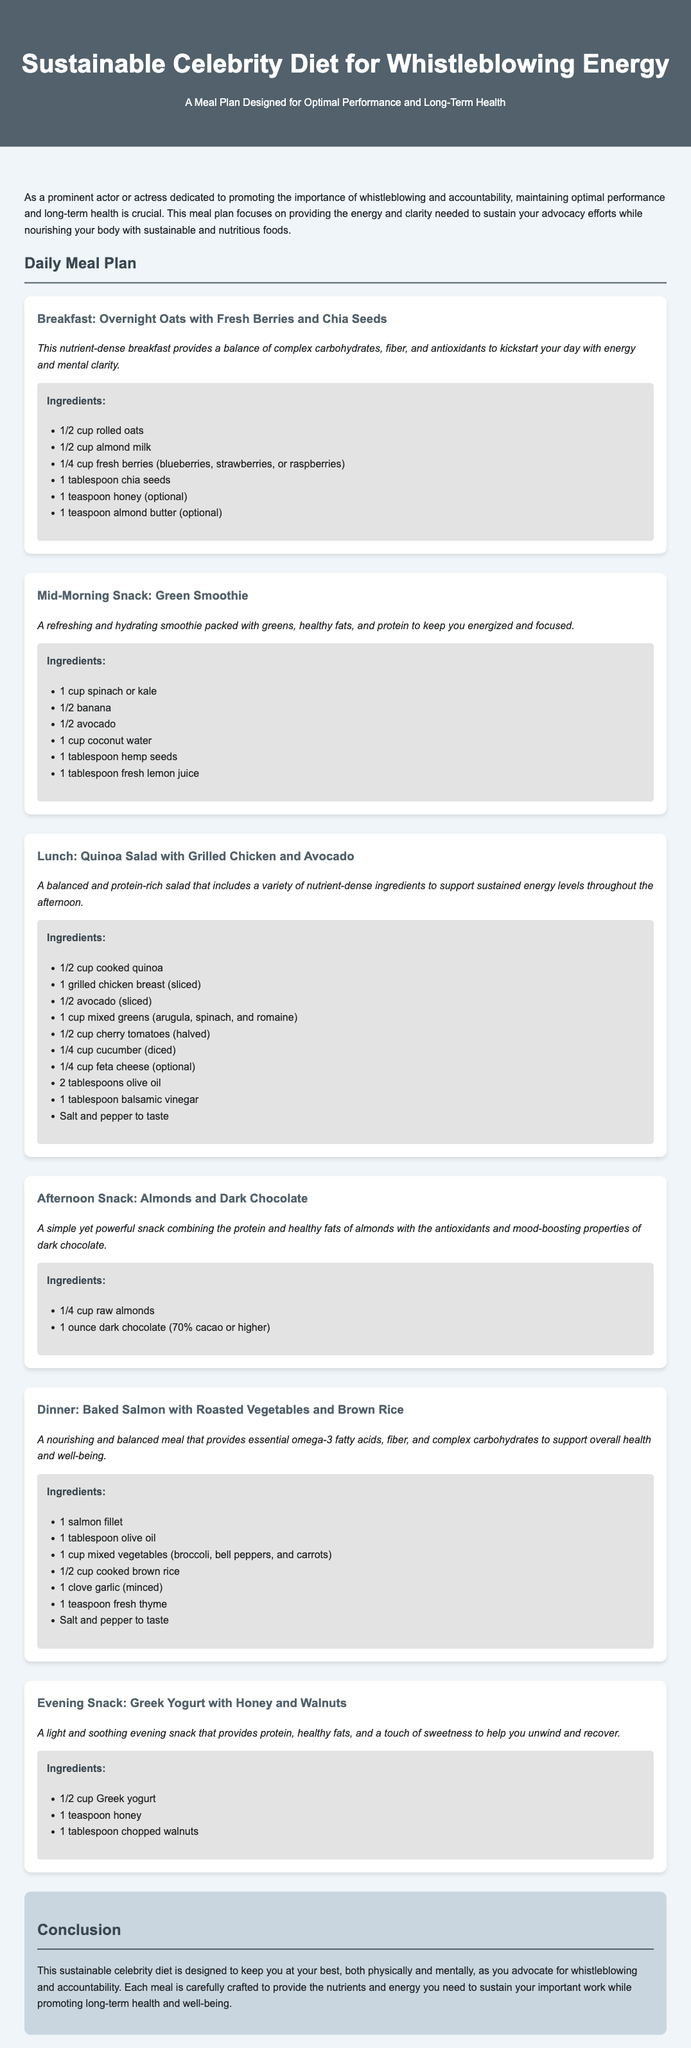What is the title of the meal plan? The title of the meal plan is prominently displayed at the top of the document.
Answer: Sustainable Celebrity Diet for Whistleblowing Energy How many meals are included in the daily meal plan? The daily meal plan consists of multiple meals including breakfast, snacks, lunch, and dinner, as listed in the document.
Answer: 6 What is the main ingredient in the breakfast meal? The breakfast meal features a key ingredient that is mentioned first in the description, focusing on its nutritional benefits.
Answer: Rolled oats Which vegetable is included in the green smoothie? The green smoothie lists specific vegetables in its ingredients.
Answer: Spinach or kale What type of fish is served for dinner? The dinner meal specifies a particular type of fish that is commonly associated with healthy eating.
Answer: Salmon What is the optional topping for the Greek yogurt? The Greek yogurt snack includes a listed optional ingredient that adds texture and flavor.
Answer: Honey What is the purpose of this meal plan? The meal plan outlines its intention at the beginning of the document, explaining its overall goal.
Answer: Optimal performance and long-term health 